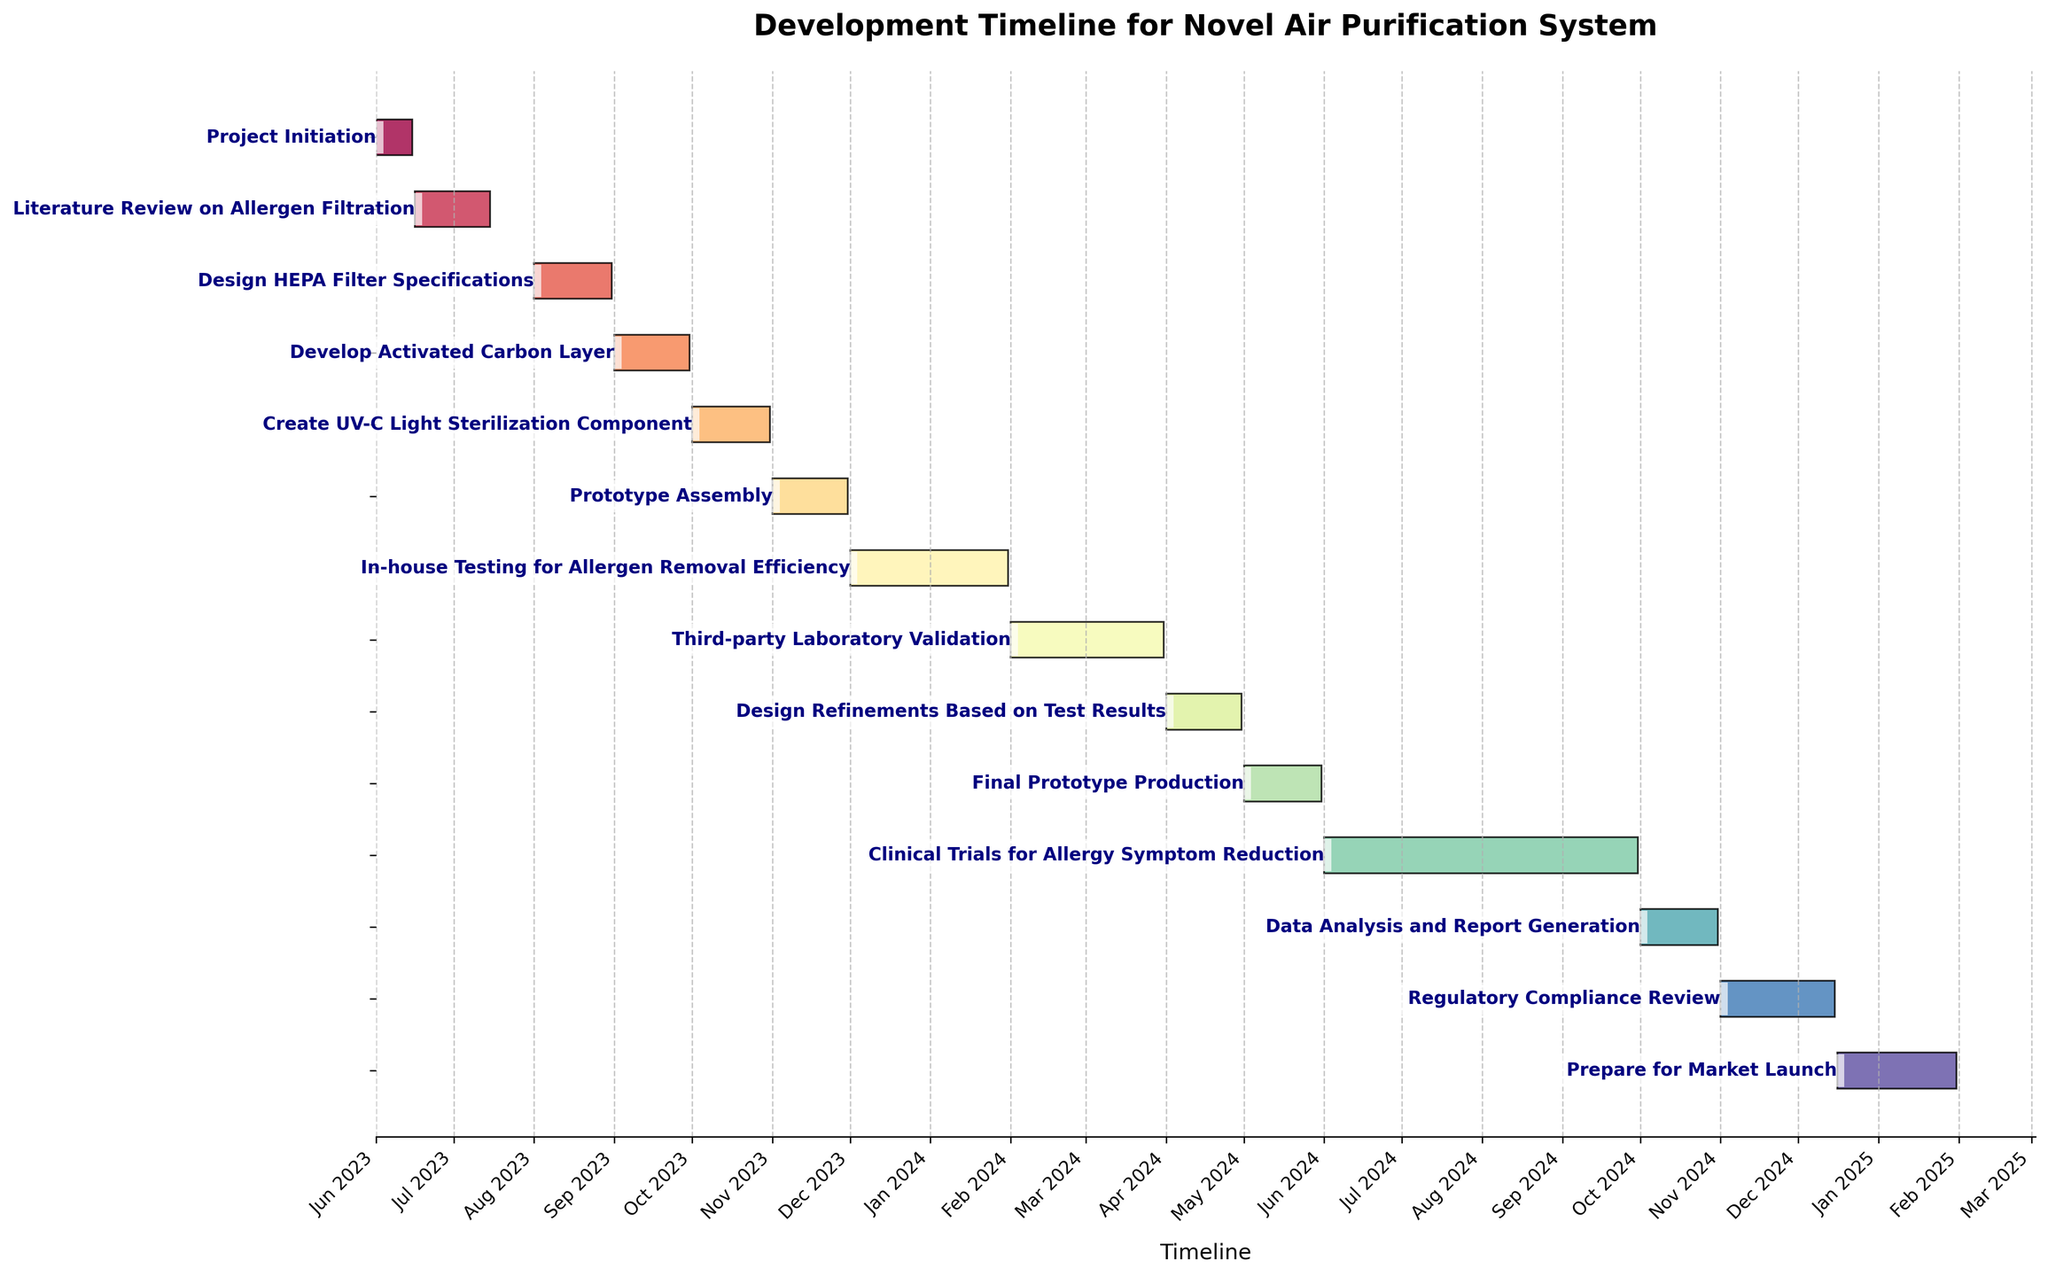What's the title of the chart? The title is the text at the top of the chart. It summarizes the subject of the visual representation. Read the top part of the figure to find it.
Answer: Development Timeline for Novel Air Purification System How many tasks are depicted in the timeline? Count the number of bars or tasks listed along the y-axis of the Gantt chart to determine the total number of tasks. Since each task corresponds to a bar, count them directly.
Answer: 14 Which task takes place immediately after "Design HEPA Filter Specifications"? Find "Design HEPA Filter Specifications" on the y-axis, then look at the task immediately following it in the timeline. The next line-up will give you the name of the succeeding task.
Answer: Develop Activated Carbon Layer During which months does the "In-house Testing for Allergen Removal Efficiency" occur? Identify the task "In-house Testing for Allergen Removal Efficiency" and look at the x-axis to determine the start and end months. Track the line from the start to the end date within the bar.
Answer: December 2023 to January 2024 What's the duration of the "Regulatory Compliance Review"? Find the "Regulatory Compliance Review" task and note the start and end dates on the x-axis. Calculate the duration by finding the difference between these dates.
Answer: 45 days Which takes longer, the "Prototype Assembly" or "Third-party Laboratory Validation"? Find both tasks on the Gantt chart, check the duration of each by observing the length of their bars or calculating the number of days from start to end. Compare both durations to determine which is longer.
Answer: Third-party Laboratory Validation What tasks are being worked on simultaneously in December 2023? Locate December 2023 along the x-axis and identify which task bars overlap within this timeframe. Observe multiple tasks during this month to see overlaps.
Answer: In-house Testing for Allergen Removal Efficiency What is the last task before the market launch? Find "Prepare for Market Launch" on the chart, then look for the task immediately preceding it. The task directly before it in the timeline sequence is the last task.
Answer: Regulatory Compliance Review How many tasks are scheduled to be completed in 2024? Look at the timeline and the bars extending through 2024, then count how many of these tasks begin and end within this year. Consider tasks that might span months.
Answer: 8 During which phase are design refinements based on test results scheduled? Identify the task "Design Refinements Based on Test Results" and note its position within the overall timeline. Observe the phase it falls into, following the progression of tasks.
Answer: Between testing and final prototype production 